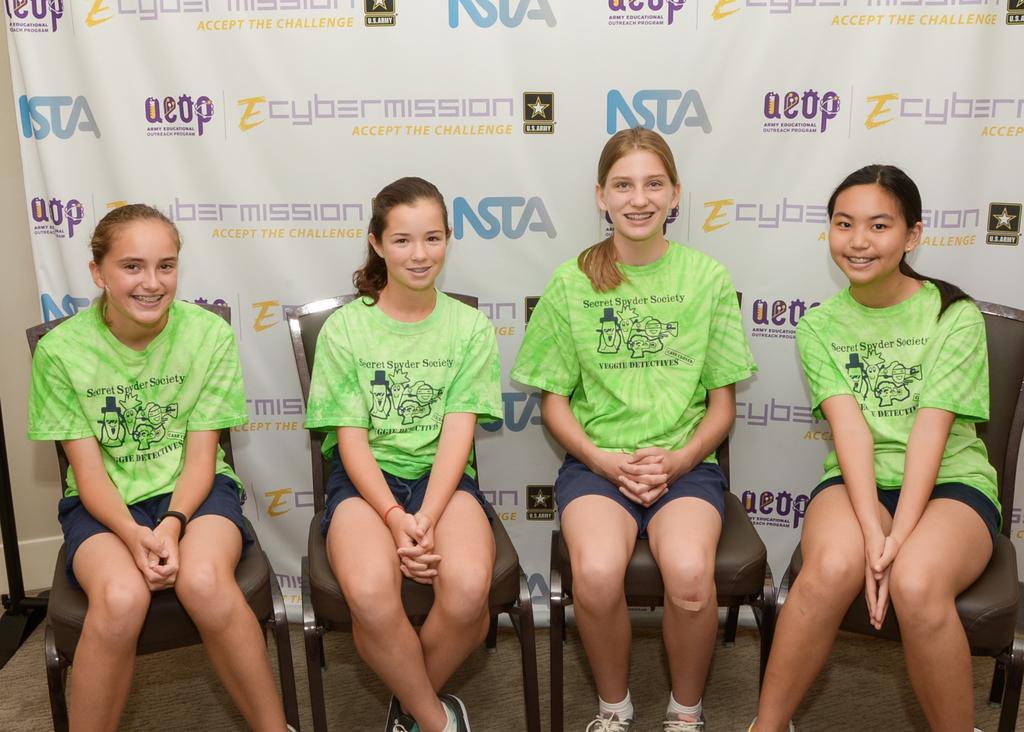Please provide a concise description of this image. This picture describe about four girls wearing green color t-shirt and shorts sitting on the chair, smiling and giving a pose in the camera. Behind we can see white color banner. 